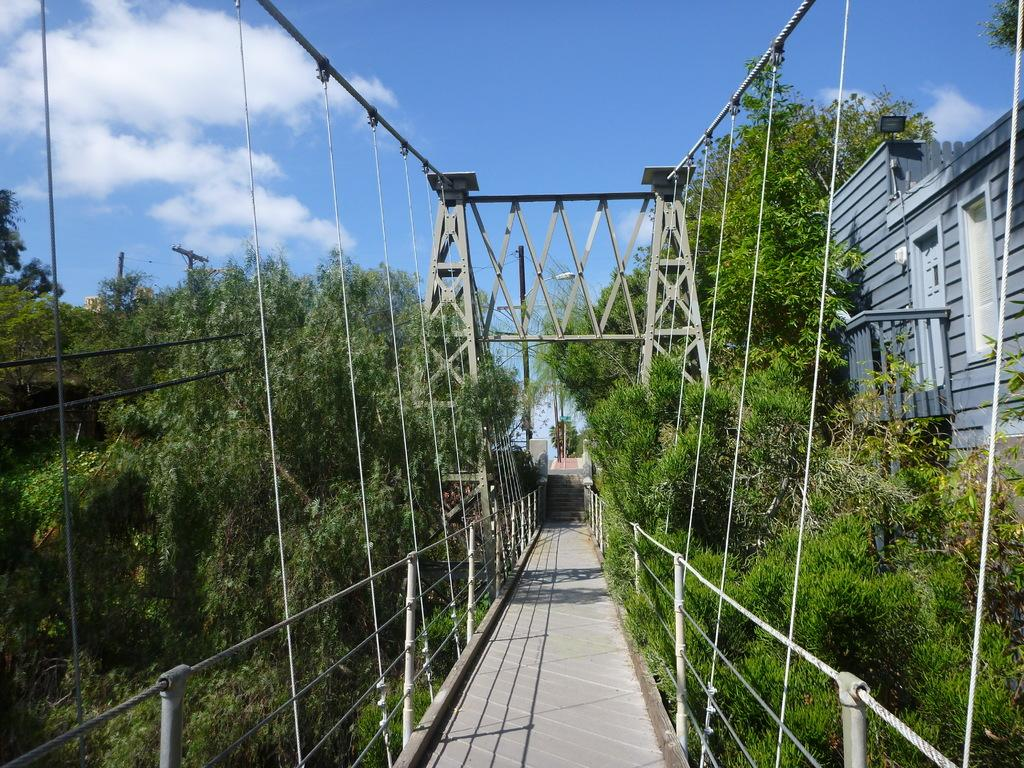What is the main structure in the middle of the image? There is a bridge in the middle of the image. What type of vegetation is present on both sides of the bridge? There are trees on both sides of the bridge. Is there any other structure visible near the trees? Yes, there is a building beside the trees. What type of polish is being applied to the bridge in the image? There is no indication in the image that any polish is being applied to the bridge. 